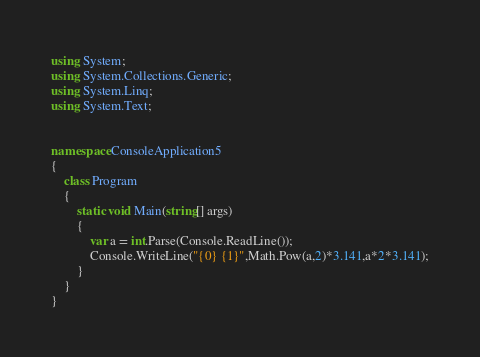Convert code to text. <code><loc_0><loc_0><loc_500><loc_500><_C#_>using System;
using System.Collections.Generic;
using System.Linq;
using System.Text;


namespace ConsoleApplication5
{
    class Program
    {
        static void Main(string[] args)
        {
            var a = int.Parse(Console.ReadLine());
            Console.WriteLine("{0} {1}",Math.Pow(a,2)*3.141,a*2*3.141);
        }
    }
}</code> 